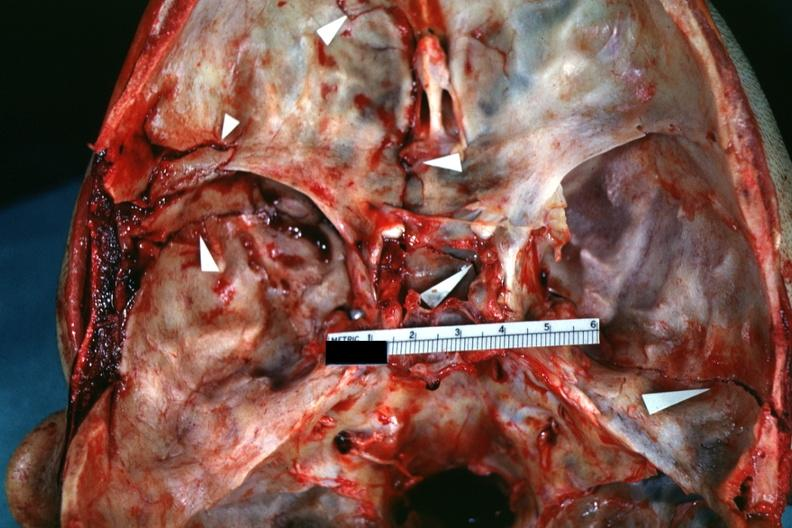what is present?
Answer the question using a single word or phrase. Bone 